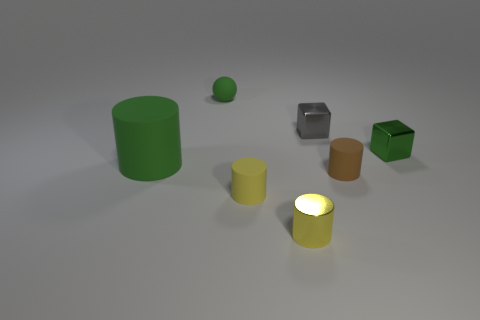What is the color of the big rubber object? green 